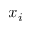<formula> <loc_0><loc_0><loc_500><loc_500>x _ { i }</formula> 